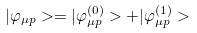Convert formula to latex. <formula><loc_0><loc_0><loc_500><loc_500>| \varphi _ { \mu { p } } > = | \varphi _ { \mu { p } } ^ { ( 0 ) } > + | \varphi _ { \mu { p } } ^ { ( 1 ) } ></formula> 